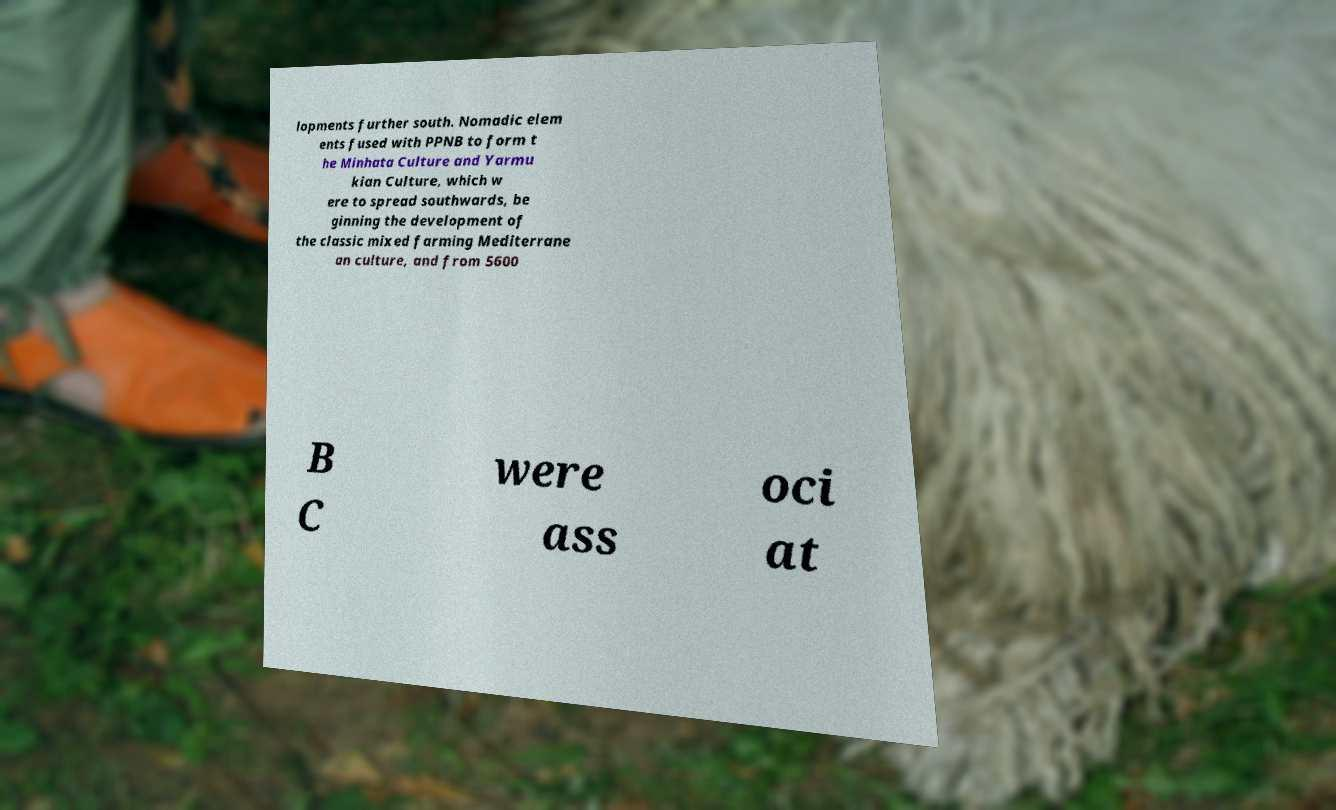I need the written content from this picture converted into text. Can you do that? lopments further south. Nomadic elem ents fused with PPNB to form t he Minhata Culture and Yarmu kian Culture, which w ere to spread southwards, be ginning the development of the classic mixed farming Mediterrane an culture, and from 5600 B C were ass oci at 